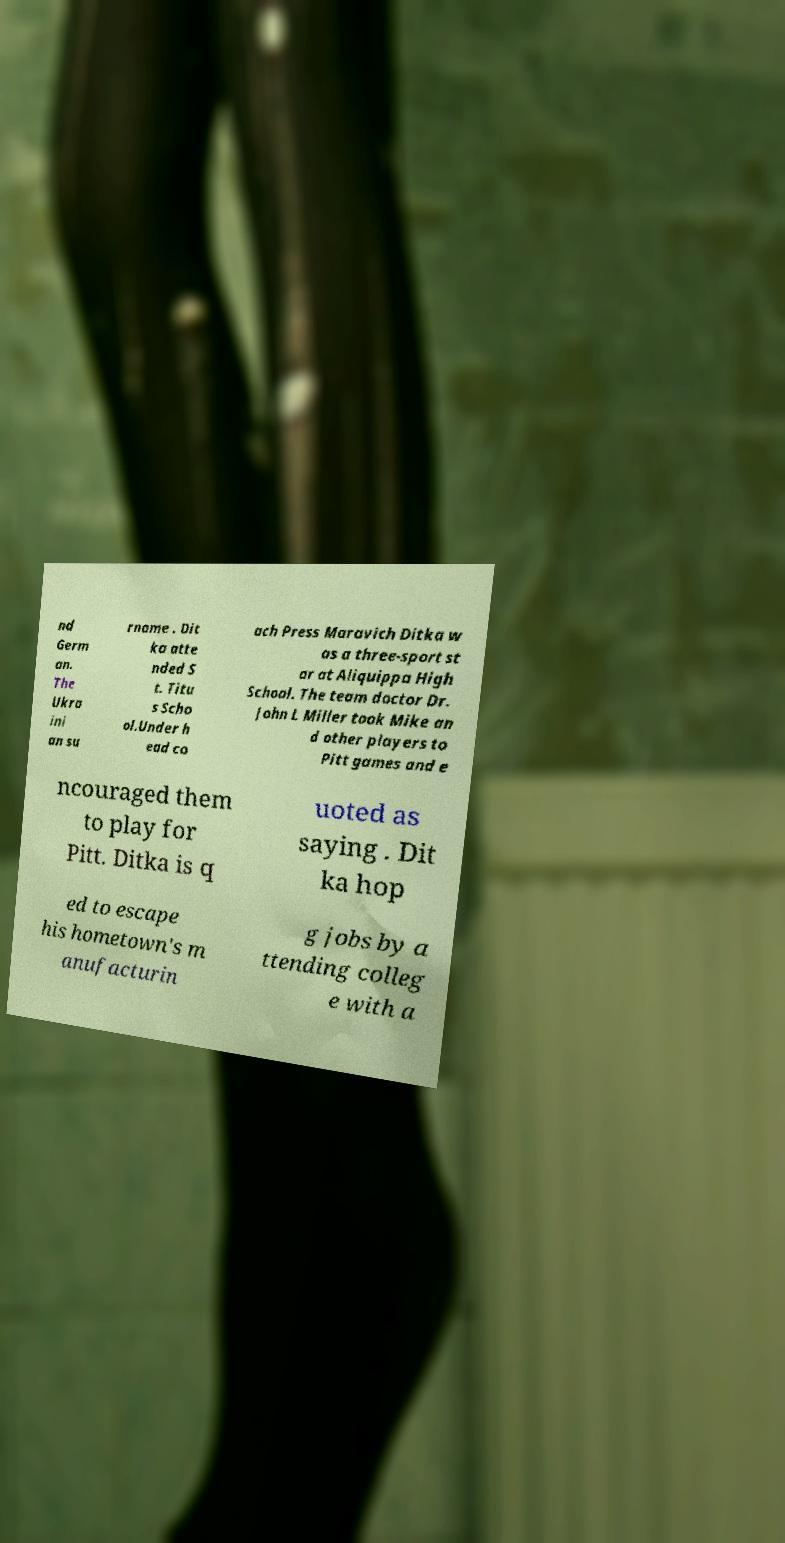What messages or text are displayed in this image? I need them in a readable, typed format. nd Germ an. The Ukra ini an su rname . Dit ka atte nded S t. Titu s Scho ol.Under h ead co ach Press Maravich Ditka w as a three-sport st ar at Aliquippa High School. The team doctor Dr. John L Miller took Mike an d other players to Pitt games and e ncouraged them to play for Pitt. Ditka is q uoted as saying . Dit ka hop ed to escape his hometown's m anufacturin g jobs by a ttending colleg e with a 